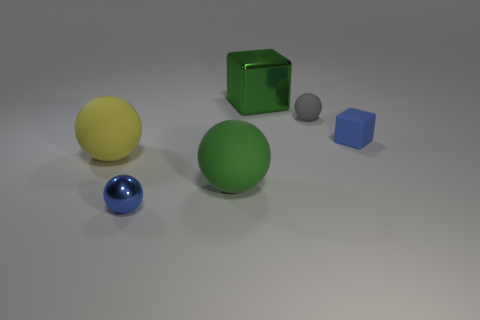Subtract all metallic spheres. How many spheres are left? 3 Add 4 yellow cylinders. How many objects exist? 10 Subtract all blue balls. How many balls are left? 3 Subtract 2 balls. How many balls are left? 2 Subtract all balls. How many objects are left? 2 Subtract all yellow cubes. Subtract all blue cylinders. How many cubes are left? 2 Subtract all small metal spheres. Subtract all small purple rubber blocks. How many objects are left? 5 Add 1 blue metal spheres. How many blue metal spheres are left? 2 Add 3 large yellow metal cylinders. How many large yellow metal cylinders exist? 3 Subtract 1 yellow balls. How many objects are left? 5 